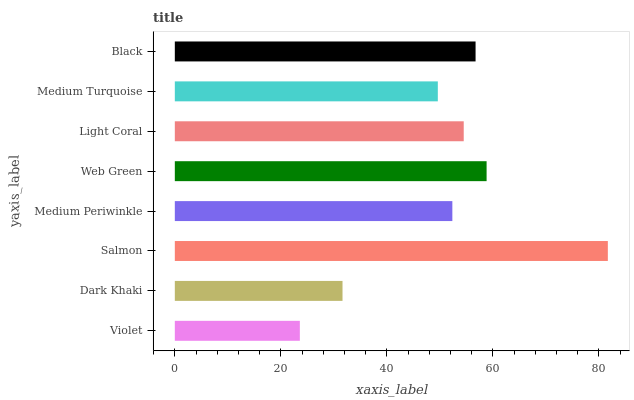Is Violet the minimum?
Answer yes or no. Yes. Is Salmon the maximum?
Answer yes or no. Yes. Is Dark Khaki the minimum?
Answer yes or no. No. Is Dark Khaki the maximum?
Answer yes or no. No. Is Dark Khaki greater than Violet?
Answer yes or no. Yes. Is Violet less than Dark Khaki?
Answer yes or no. Yes. Is Violet greater than Dark Khaki?
Answer yes or no. No. Is Dark Khaki less than Violet?
Answer yes or no. No. Is Light Coral the high median?
Answer yes or no. Yes. Is Medium Periwinkle the low median?
Answer yes or no. Yes. Is Web Green the high median?
Answer yes or no. No. Is Violet the low median?
Answer yes or no. No. 